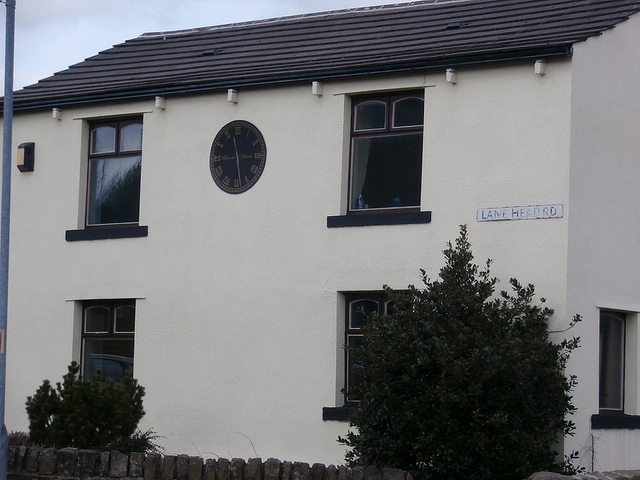<image>Which window's shutters are fully open? It is ambiguous which window's shutters are fully open. It could be none, all, or the rightmost. Is this building handicap accessible? I don't know if this building is handicap accessible. It seems that it might not be, but there is a possibility that it is. Which window's shutters are fully open? I don't know which window's shutters are fully open. It is not specified. Is this building handicap accessible? I don't know if this building is handicap accessible. It seems that it is not. 